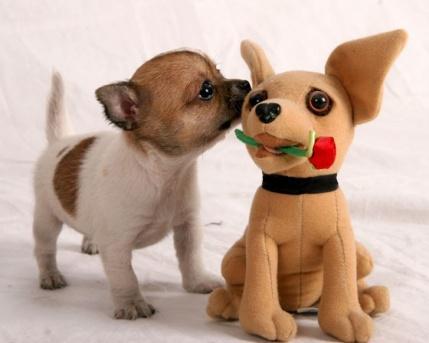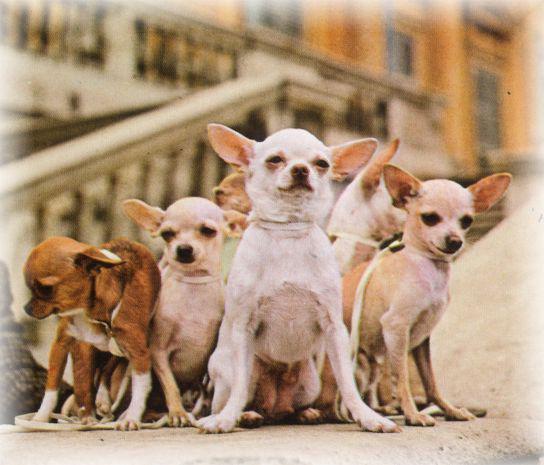The first image is the image on the left, the second image is the image on the right. Analyze the images presented: Is the assertion "There is exactly one real dog in the image on the left." valid? Answer yes or no. Yes. 